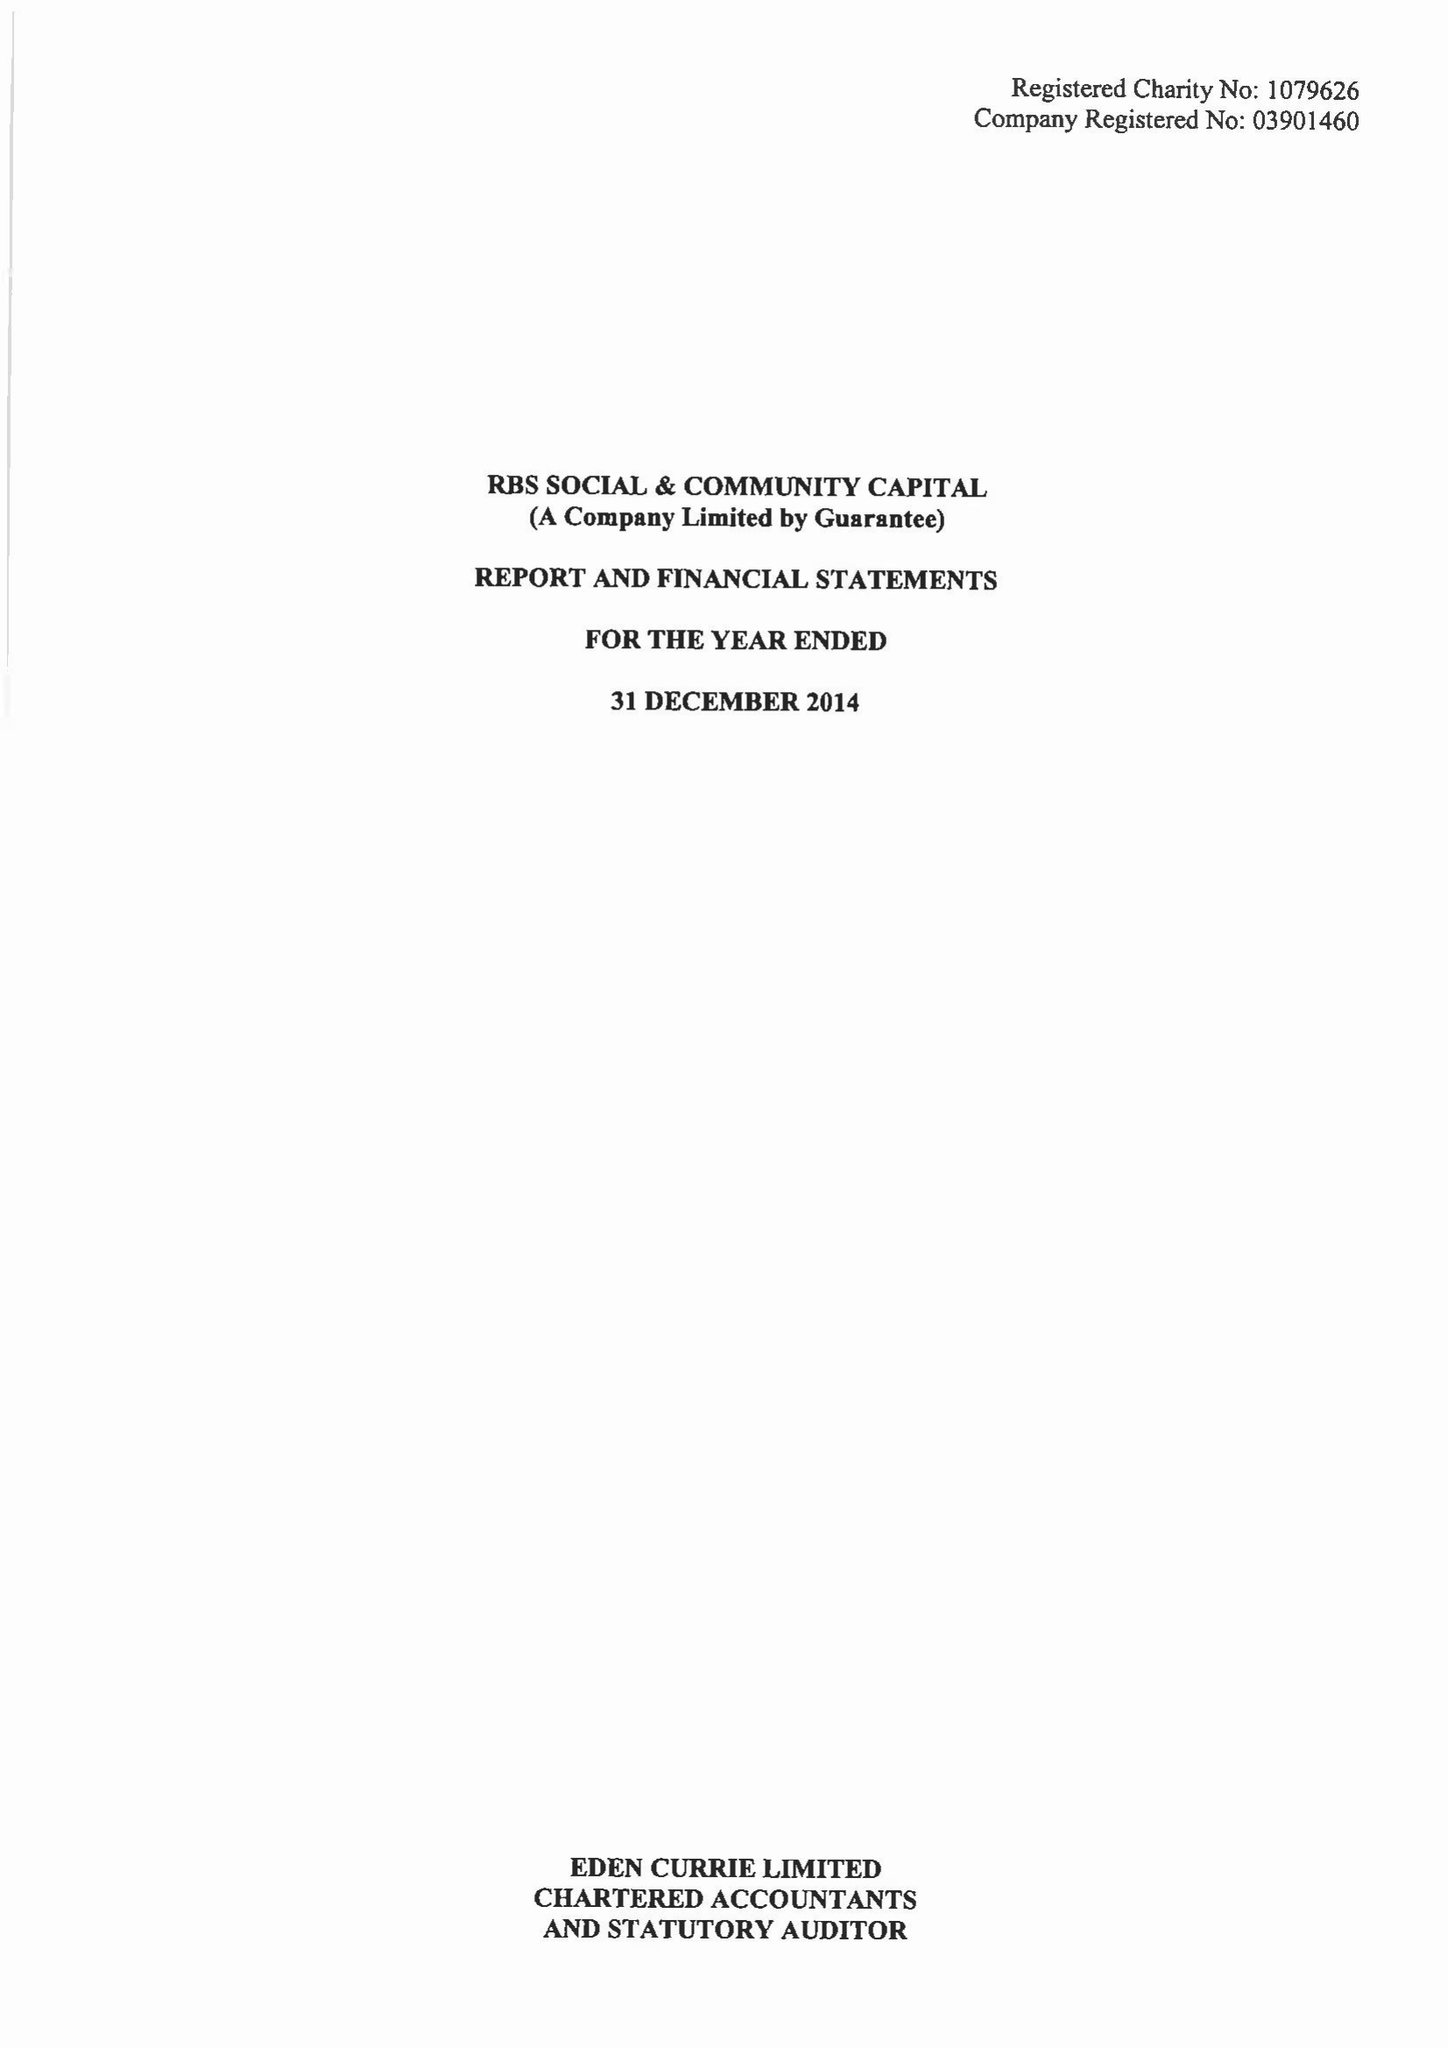What is the value for the address__post_town?
Answer the question using a single word or phrase. LONDON 